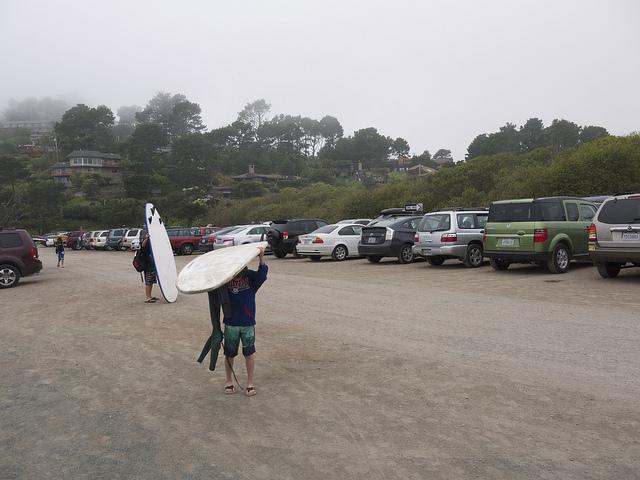What is this person carrying?
Keep it brief. Surfboard. What is all over the ground?
Be succinct. Sand. How must it feel to be riding on the waves with a surfboard?
Concise answer only. Fun. How many cars?
Give a very brief answer. 20. What color are the surfboards?
Quick response, please. White. 